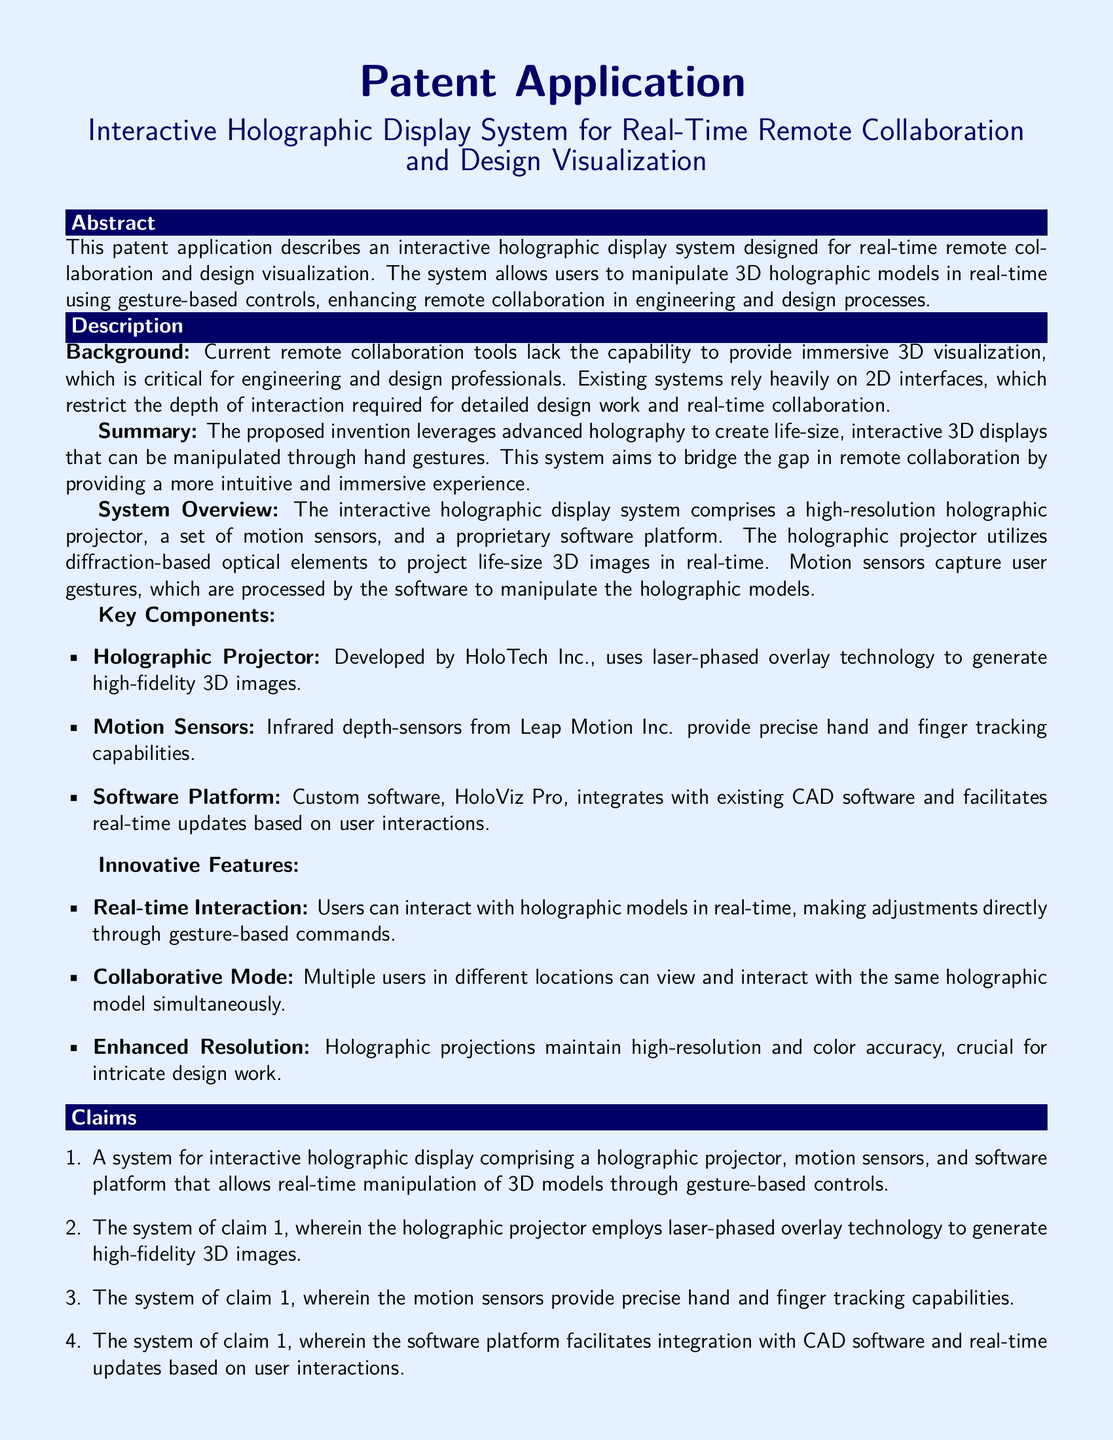What is the title of the patent application? The title is presented prominently at the beginning of the document, summarizing the invention's core purpose and functionality.
Answer: Interactive Holographic Display System for Real-Time Remote Collaboration and Design Visualization Who developed the holographic projector? The document specifies that HoloTech Inc. is responsible for developing the holographic projector, a key component of the system.
Answer: HoloTech Inc What technology does the holographic projector use? The specific technology utilized by the holographic projector is mentioned in the description of the key components in the document.
Answer: Laser-phased overlay technology How many key components are listed in the system overview? The number of components is detailed in the key components section, indicating the structural elements of the invention.
Answer: Three What is the name of the software platform? The document explicitly mentions the proprietary software designed to support the holographic display system.
Answer: HoloViz Pro What is one potential application mentioned for the system? The document lists various potential applications of the system, indicating its versatility in different fields.
Answer: Engineering design reviews Which company provides motion sensors? The incumbent supplier of motion sensors is identified in the description of the system's key components.
Answer: Leap Motion Inc What type of tracking capabilities do the motion sensors provide? The document outlines a specific capability of the motion sensors, elucidating their role in the interactive system.
Answer: Precise hand and finger tracking capabilities 